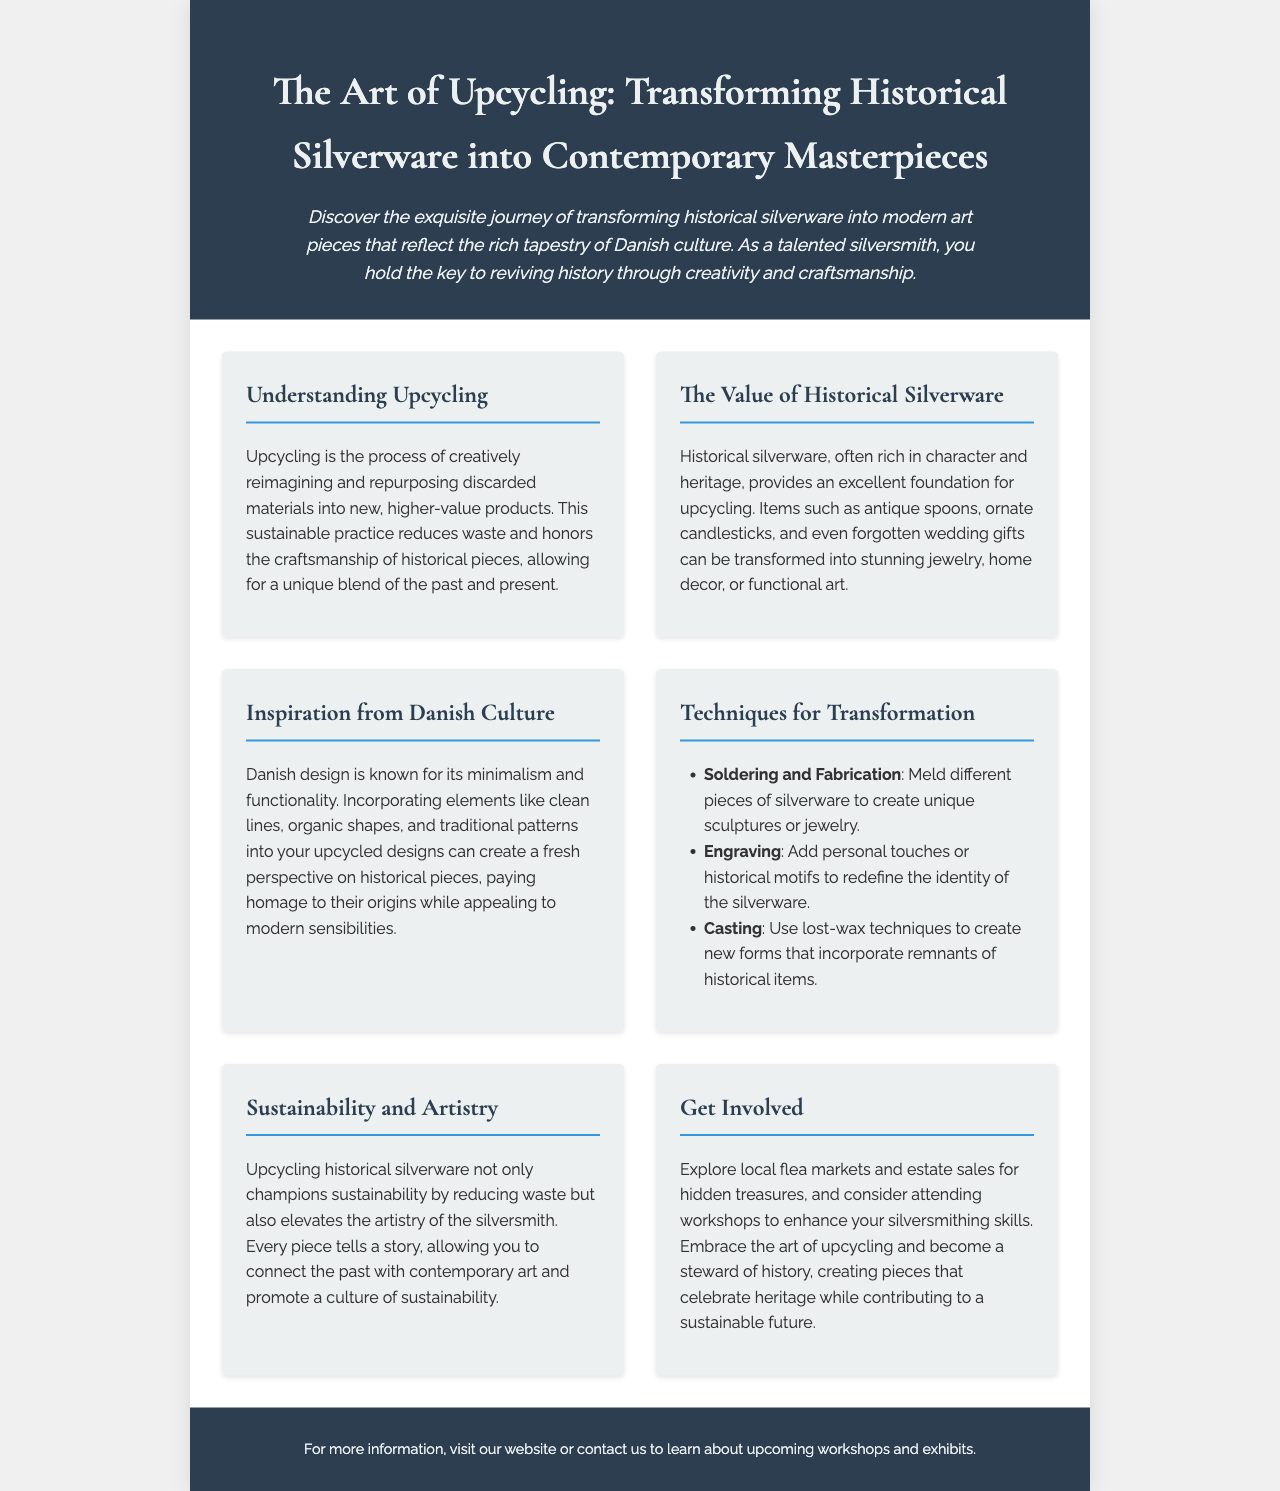What is upcycling? Upcycling is defined in the document as creatively reimagining and repurposing discarded materials into new, higher-value products.
Answer: creatively reimagining and repurposing discarded materials What type of items can be transformed through upcycling? The document lists examples like antique spoons, ornate candlesticks, and forgotten wedding gifts as items suitable for transformation.
Answer: antique spoons, ornate candlesticks, forgotten wedding gifts What design style is emphasized in Danish culture? The brochure mentions that Danish design is known for its minimalism and functionality.
Answer: minimalism and functionality Name one technique for transformation mentioned. The document lists several techniques, one of which is soldering and fabrication.
Answer: soldering and fabrication What does upcycling do in terms of sustainability? The text states that upcycling champions sustainability by reducing waste.
Answer: reduces waste What should silversmiths explore for hidden treasures? The brochure suggests exploring local flea markets and estate sales for hidden treasures.
Answer: local flea markets and estate sales What does each piece created through upcycling represent? The document emphasizes that every piece tells a story, connecting the past with contemporary art.
Answer: tells a story What can silversmiths do to enhance their skills? The document encourages attending workshops to enhance silversmithing skills.
Answer: attending workshops 